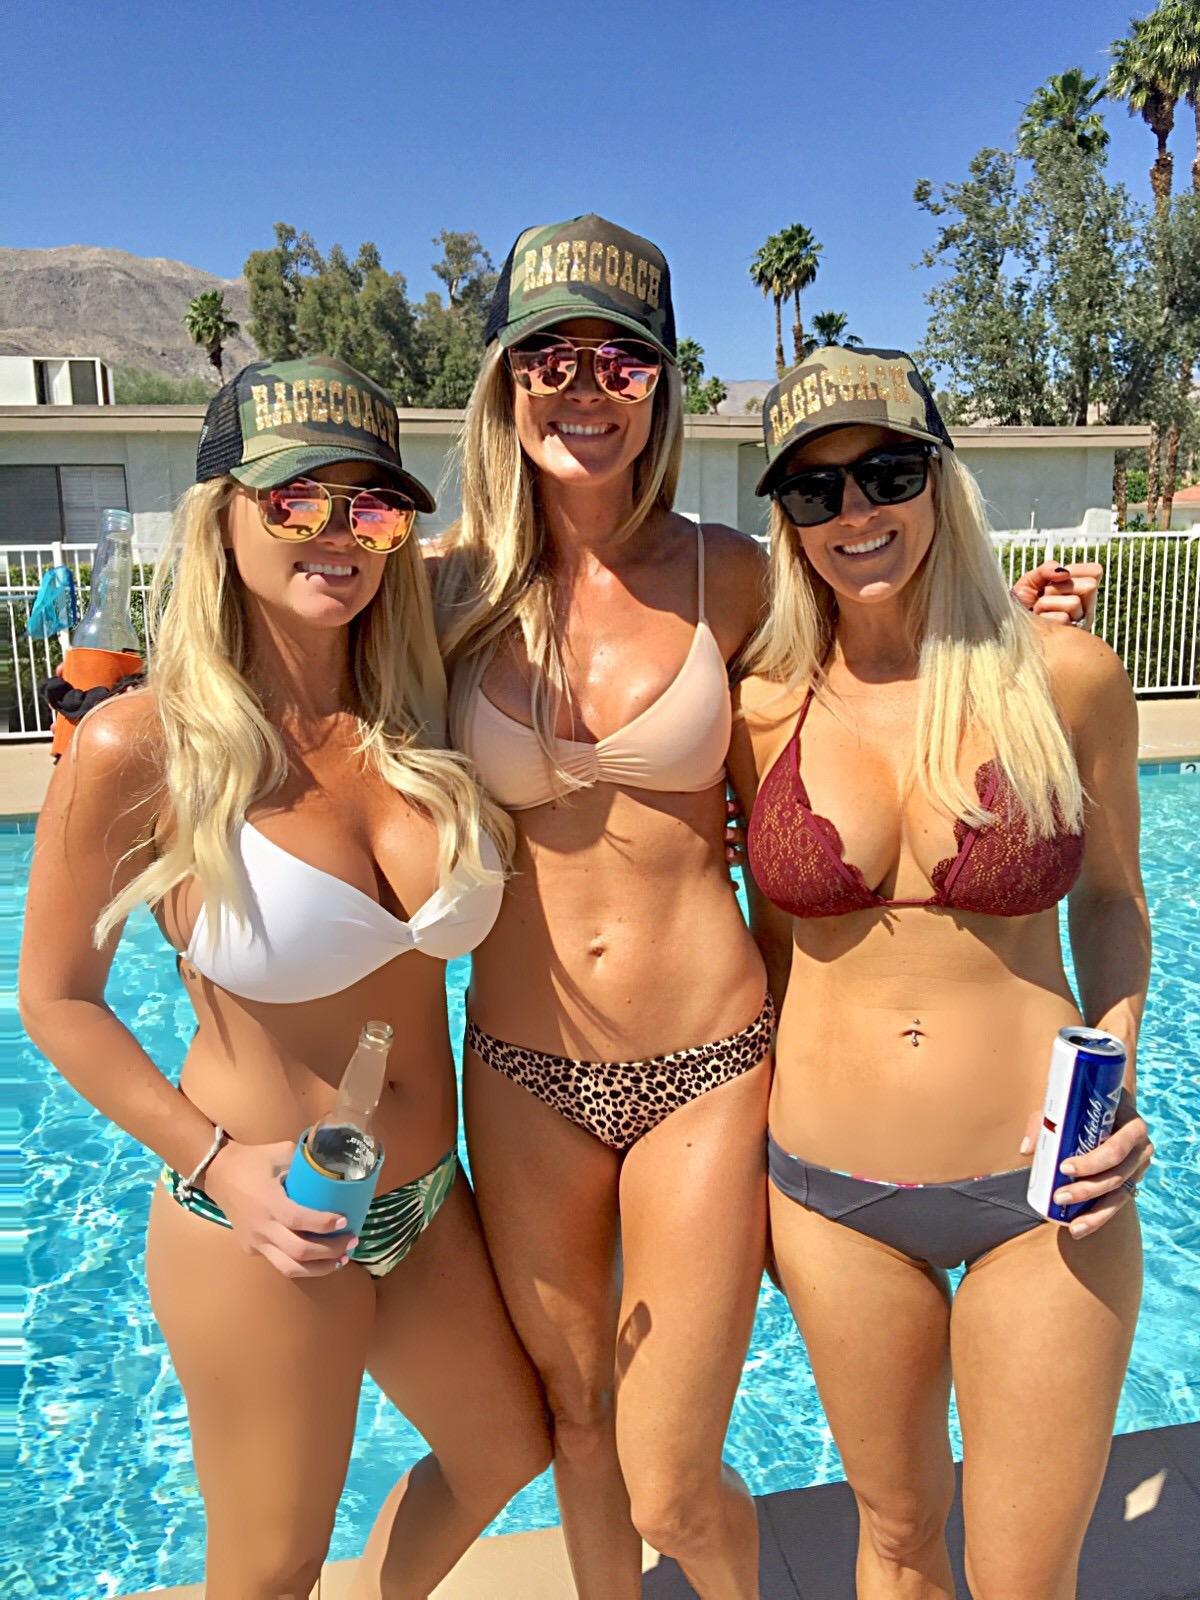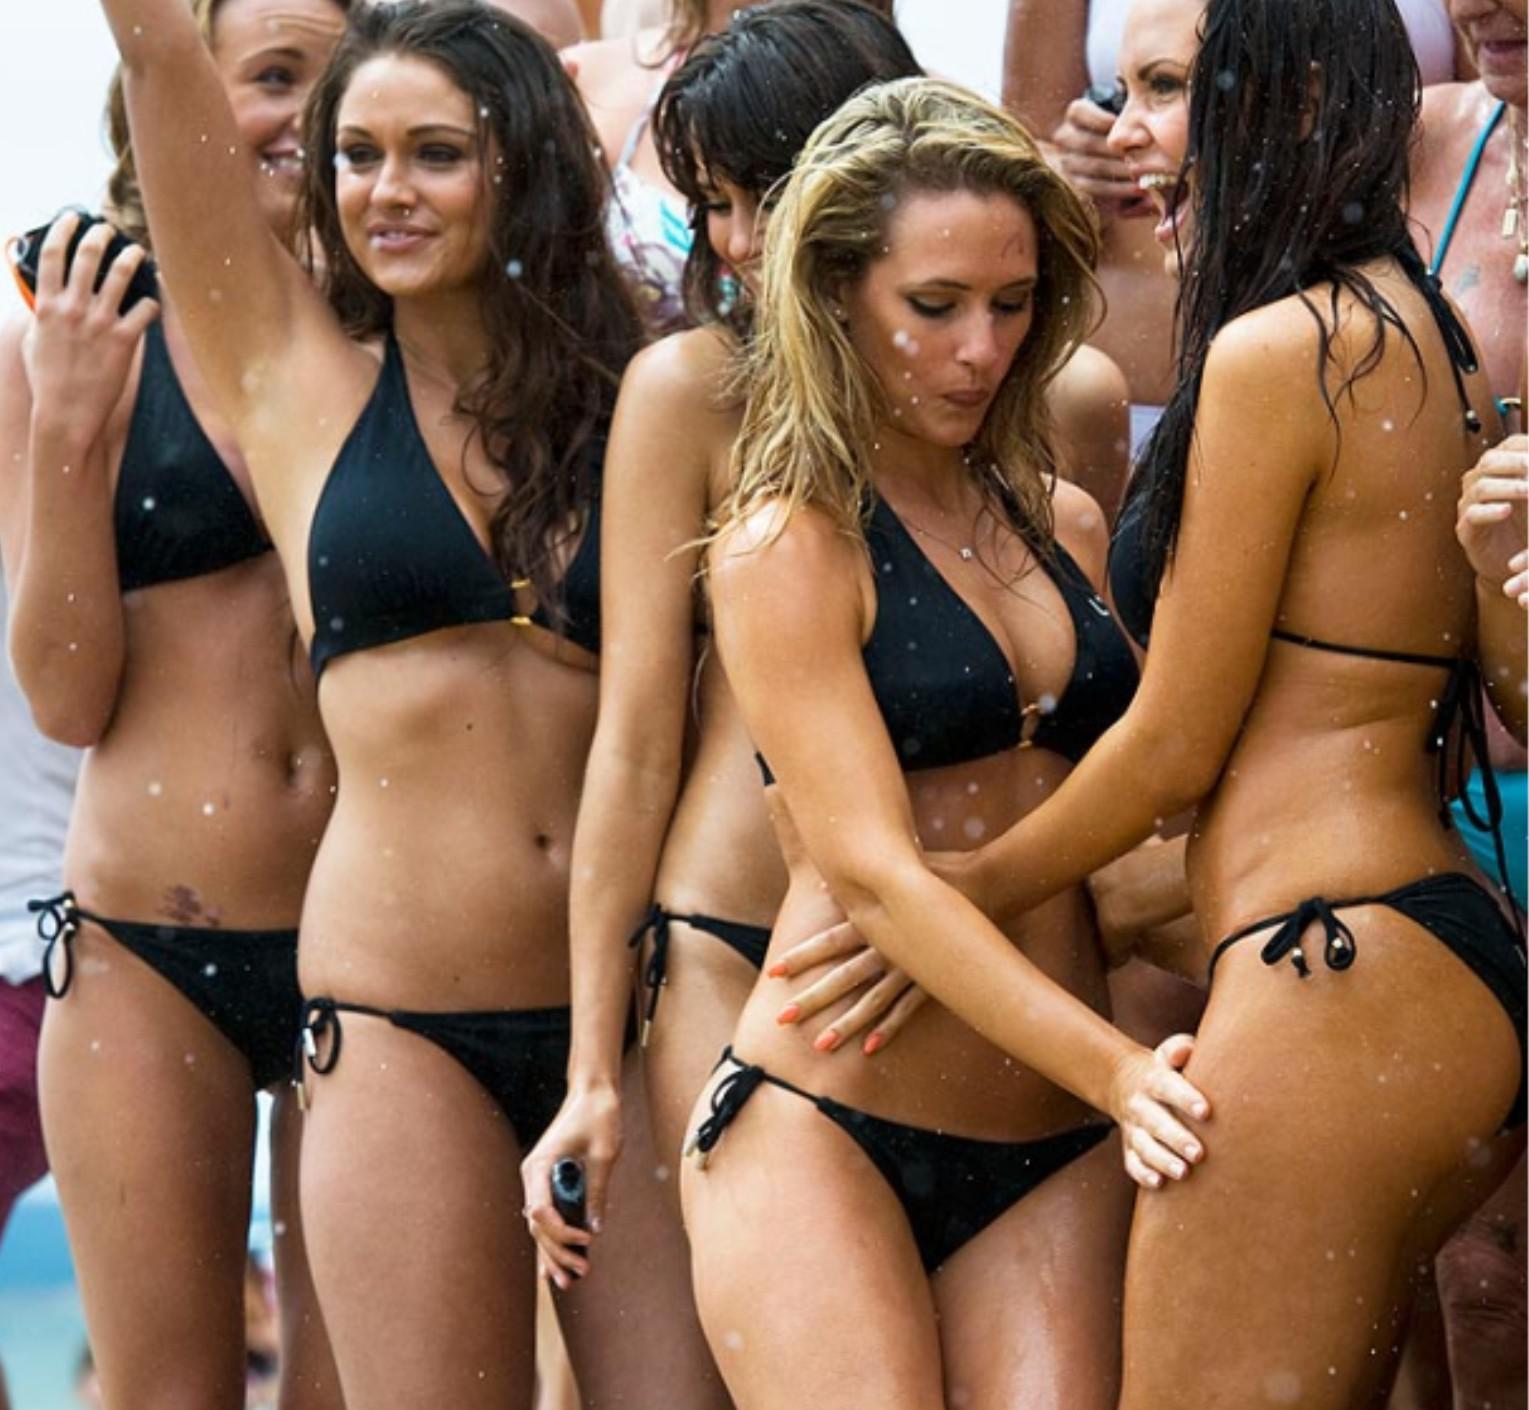The first image is the image on the left, the second image is the image on the right. For the images shown, is this caption "There are exactly three girls standing in one of the images." true? Answer yes or no. Yes. 